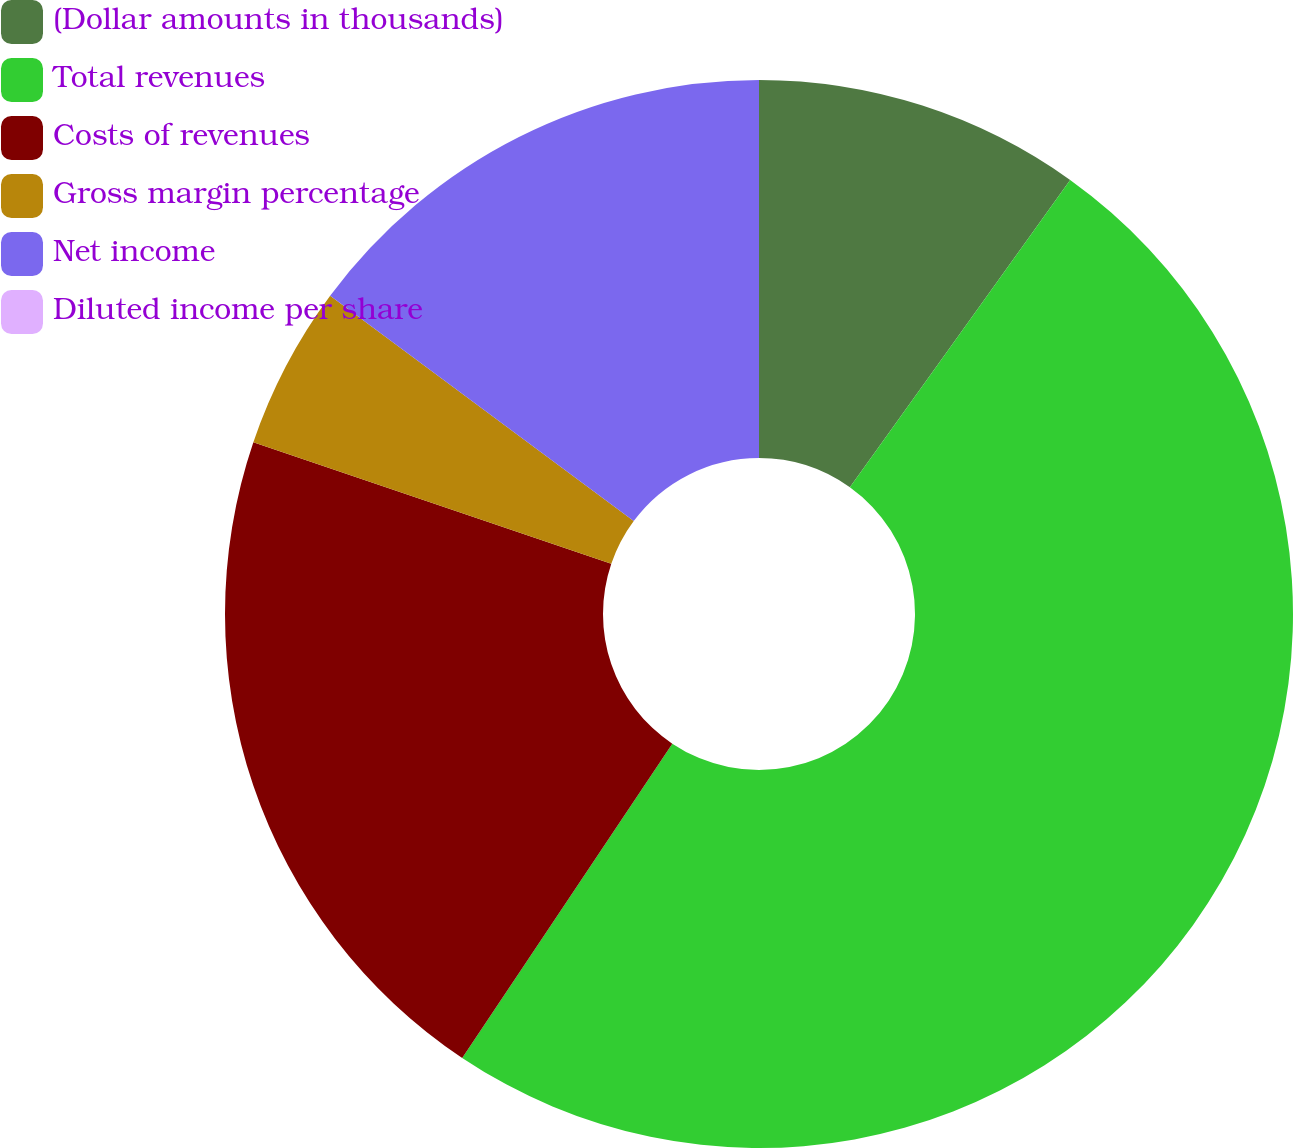Convert chart to OTSL. <chart><loc_0><loc_0><loc_500><loc_500><pie_chart><fcel>(Dollar amounts in thousands)<fcel>Total revenues<fcel>Costs of revenues<fcel>Gross margin percentage<fcel>Net income<fcel>Diluted income per share<nl><fcel>9.9%<fcel>49.48%<fcel>20.83%<fcel>4.95%<fcel>14.84%<fcel>0.0%<nl></chart> 